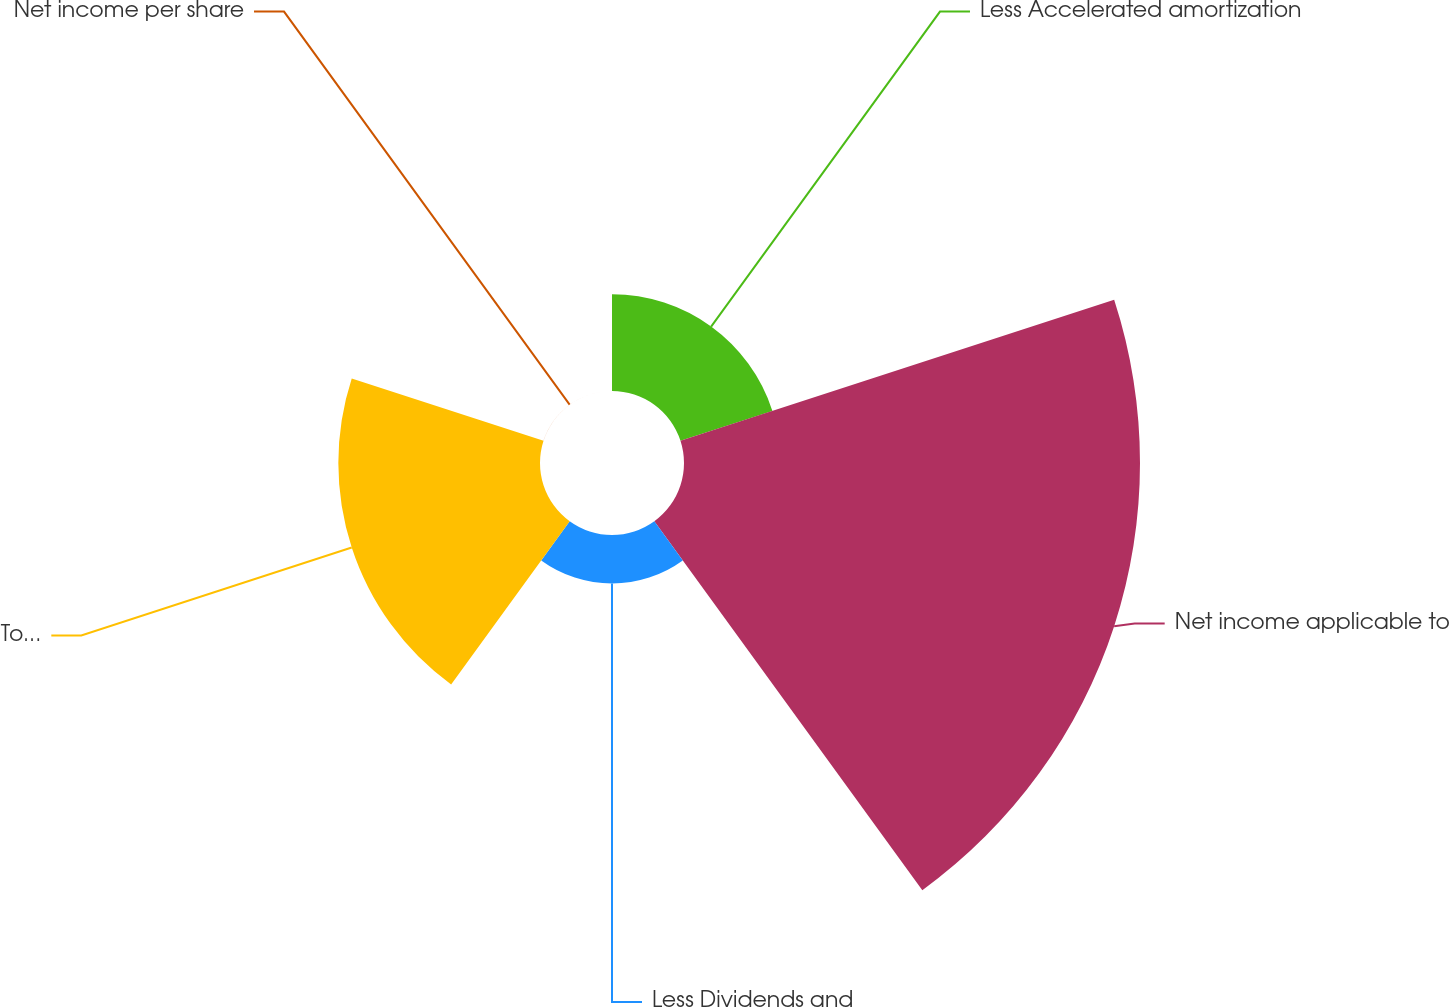<chart> <loc_0><loc_0><loc_500><loc_500><pie_chart><fcel>Less Accelerated amortization<fcel>Net income applicable to<fcel>Less Dividends and<fcel>Total weighted average diluted<fcel>Net income per share<nl><fcel>12.04%<fcel>56.8%<fcel>6.03%<fcel>25.12%<fcel>0.01%<nl></chart> 